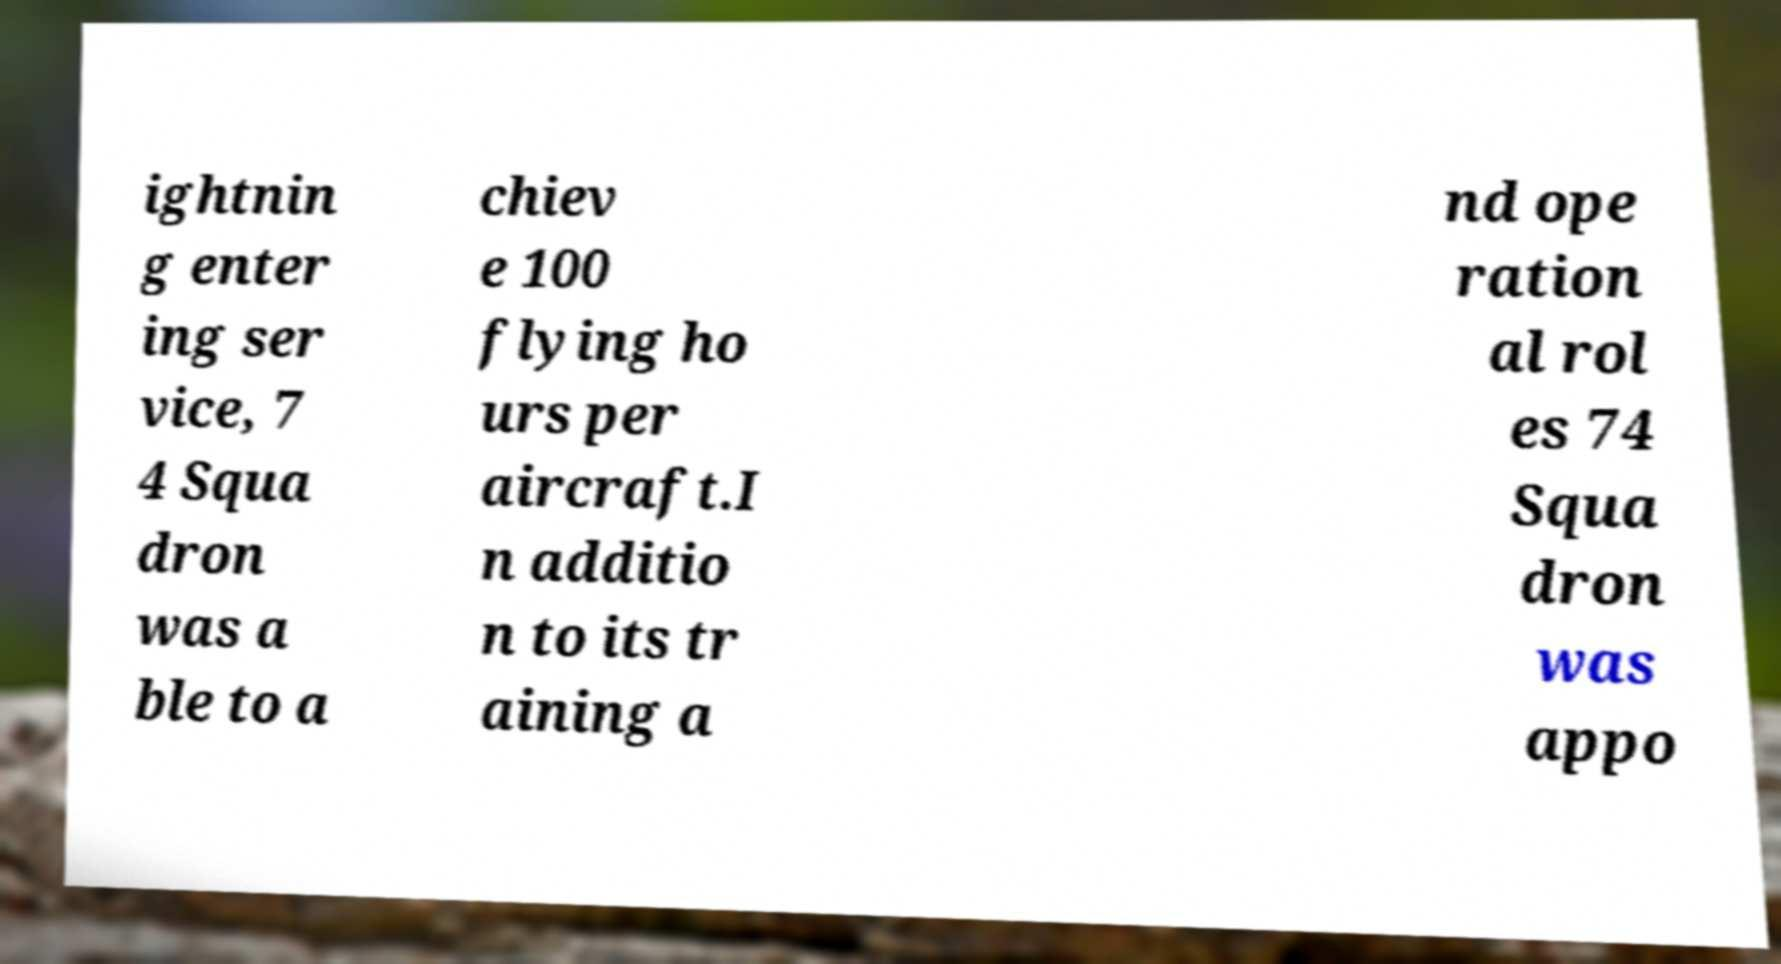Please identify and transcribe the text found in this image. ightnin g enter ing ser vice, 7 4 Squa dron was a ble to a chiev e 100 flying ho urs per aircraft.I n additio n to its tr aining a nd ope ration al rol es 74 Squa dron was appo 